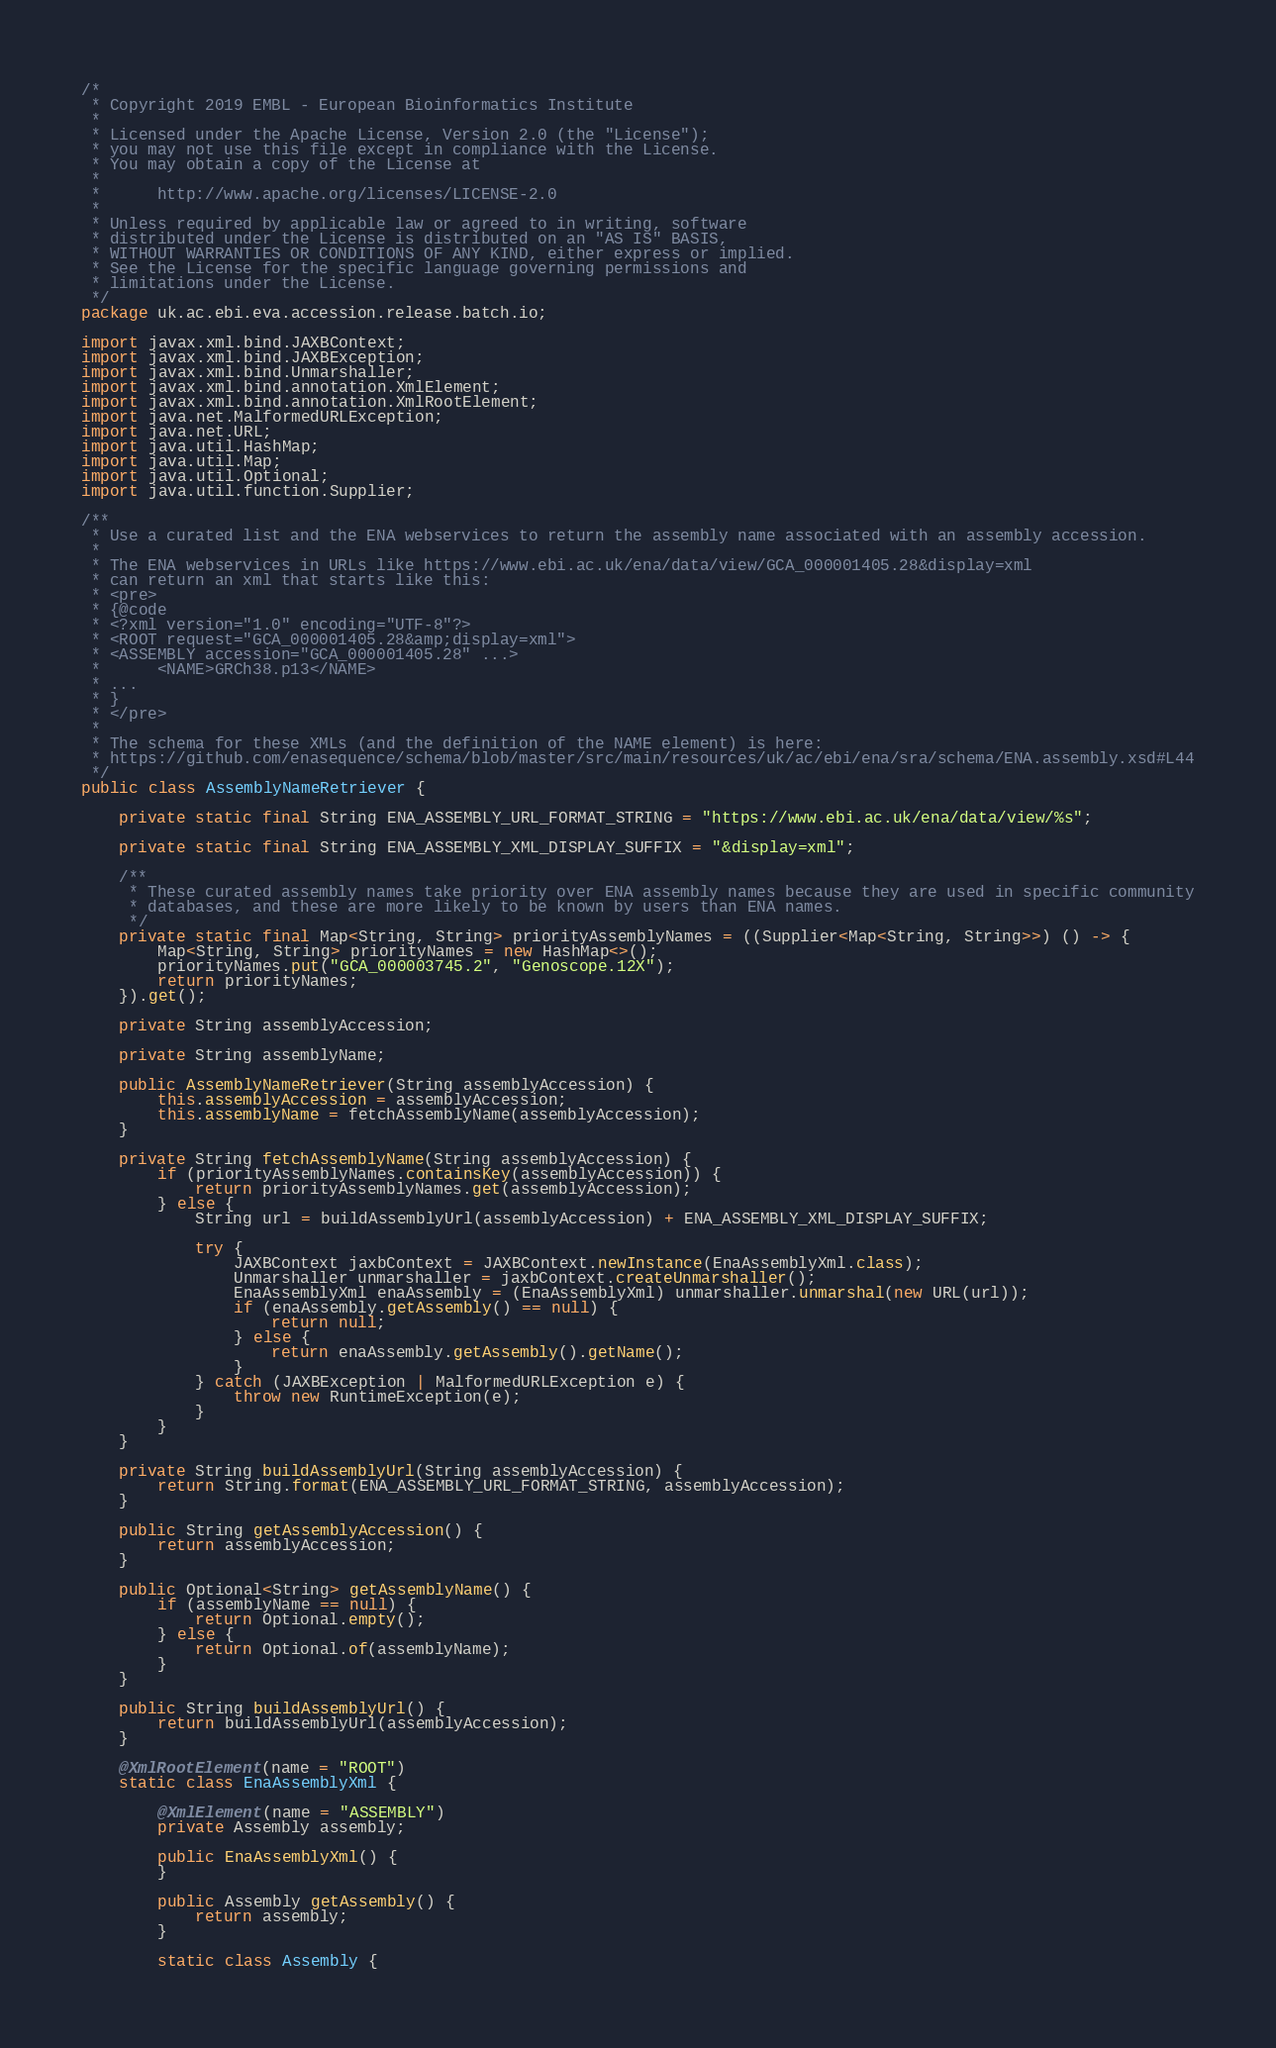<code> <loc_0><loc_0><loc_500><loc_500><_Java_>/*
 * Copyright 2019 EMBL - European Bioinformatics Institute
 *
 * Licensed under the Apache License, Version 2.0 (the "License");
 * you may not use this file except in compliance with the License.
 * You may obtain a copy of the License at
 *
 *      http://www.apache.org/licenses/LICENSE-2.0
 *
 * Unless required by applicable law or agreed to in writing, software
 * distributed under the License is distributed on an "AS IS" BASIS,
 * WITHOUT WARRANTIES OR CONDITIONS OF ANY KIND, either express or implied.
 * See the License for the specific language governing permissions and
 * limitations under the License.
 */
package uk.ac.ebi.eva.accession.release.batch.io;

import javax.xml.bind.JAXBContext;
import javax.xml.bind.JAXBException;
import javax.xml.bind.Unmarshaller;
import javax.xml.bind.annotation.XmlElement;
import javax.xml.bind.annotation.XmlRootElement;
import java.net.MalformedURLException;
import java.net.URL;
import java.util.HashMap;
import java.util.Map;
import java.util.Optional;
import java.util.function.Supplier;

/**
 * Use a curated list and the ENA webservices to return the assembly name associated with an assembly accession.
 *
 * The ENA webservices in URLs like https://www.ebi.ac.uk/ena/data/view/GCA_000001405.28&display=xml
 * can return an xml that starts like this:
 * <pre>
 * {@code
 * <?xml version="1.0" encoding="UTF-8"?>
 * <ROOT request="GCA_000001405.28&amp;display=xml">
 * <ASSEMBLY accession="GCA_000001405.28" ...>
 *      <NAME>GRCh38.p13</NAME>
 * ...
 * }
 * </pre>
 *
 * The schema for these XMLs (and the definition of the NAME element) is here:
 * https://github.com/enasequence/schema/blob/master/src/main/resources/uk/ac/ebi/ena/sra/schema/ENA.assembly.xsd#L44
 */
public class AssemblyNameRetriever {

    private static final String ENA_ASSEMBLY_URL_FORMAT_STRING = "https://www.ebi.ac.uk/ena/data/view/%s";

    private static final String ENA_ASSEMBLY_XML_DISPLAY_SUFFIX = "&display=xml";

    /**
     * These curated assembly names take priority over ENA assembly names because they are used in specific community
     * databases, and these are more likely to be known by users than ENA names.
     */
    private static final Map<String, String> priorityAssemblyNames = ((Supplier<Map<String, String>>) () -> {
        Map<String, String> priorityNames = new HashMap<>();
        priorityNames.put("GCA_000003745.2", "Genoscope.12X");
        return priorityNames;
    }).get();

    private String assemblyAccession;

    private String assemblyName;

    public AssemblyNameRetriever(String assemblyAccession) {
        this.assemblyAccession = assemblyAccession;
        this.assemblyName = fetchAssemblyName(assemblyAccession);
    }

    private String fetchAssemblyName(String assemblyAccession) {
        if (priorityAssemblyNames.containsKey(assemblyAccession)) {
            return priorityAssemblyNames.get(assemblyAccession);
        } else {
            String url = buildAssemblyUrl(assemblyAccession) + ENA_ASSEMBLY_XML_DISPLAY_SUFFIX;

            try {
                JAXBContext jaxbContext = JAXBContext.newInstance(EnaAssemblyXml.class);
                Unmarshaller unmarshaller = jaxbContext.createUnmarshaller();
                EnaAssemblyXml enaAssembly = (EnaAssemblyXml) unmarshaller.unmarshal(new URL(url));
                if (enaAssembly.getAssembly() == null) {
                    return null;
                } else {
                    return enaAssembly.getAssembly().getName();
                }
            } catch (JAXBException | MalformedURLException e) {
                throw new RuntimeException(e);
            }
        }
    }

    private String buildAssemblyUrl(String assemblyAccession) {
        return String.format(ENA_ASSEMBLY_URL_FORMAT_STRING, assemblyAccession);
    }

    public String getAssemblyAccession() {
        return assemblyAccession;
    }

    public Optional<String> getAssemblyName() {
        if (assemblyName == null) {
            return Optional.empty();
        } else {
            return Optional.of(assemblyName);
        }
    }

    public String buildAssemblyUrl() {
        return buildAssemblyUrl(assemblyAccession);
    }

    @XmlRootElement(name = "ROOT")
    static class EnaAssemblyXml {

        @XmlElement(name = "ASSEMBLY")
        private Assembly assembly;

        public EnaAssemblyXml() {
        }

        public Assembly getAssembly() {
            return assembly;
        }

        static class Assembly {
</code> 